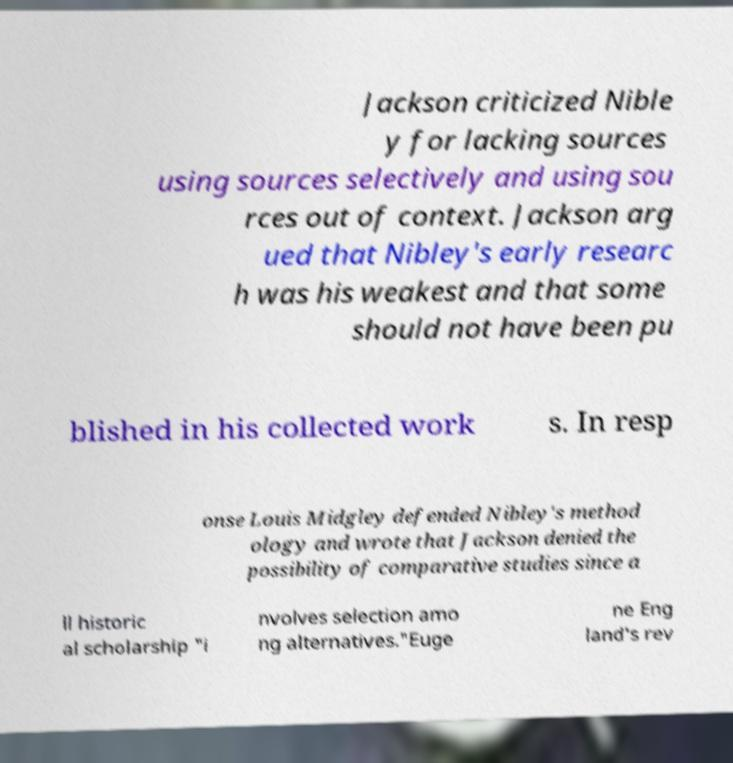Could you assist in decoding the text presented in this image and type it out clearly? Jackson criticized Nible y for lacking sources using sources selectively and using sou rces out of context. Jackson arg ued that Nibley's early researc h was his weakest and that some should not have been pu blished in his collected work s. In resp onse Louis Midgley defended Nibley's method ology and wrote that Jackson denied the possibility of comparative studies since a ll historic al scholarship "i nvolves selection amo ng alternatives."Euge ne Eng land's rev 